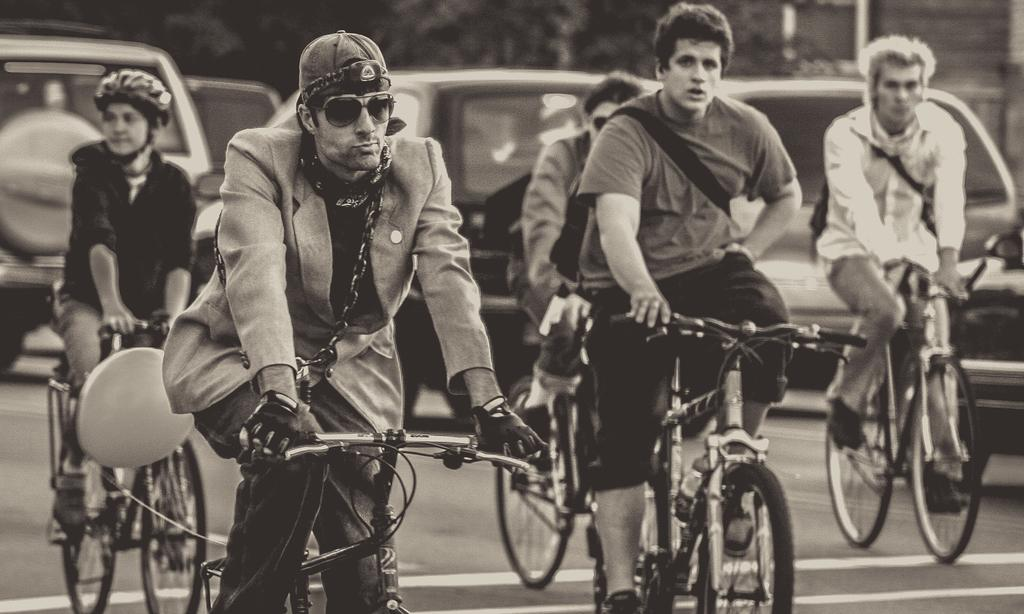What are the people in the image doing? The people in the image are riding bicycles. What else can be seen on the road in the image? There are vehicles on the road in the image. What is the color scheme of the image? The image is black and white. Where is the market located in the image? There is no market present in the image. Can you tell me how many people are walking on the sidewalk in the image? There is no sidewalk present in the image. 